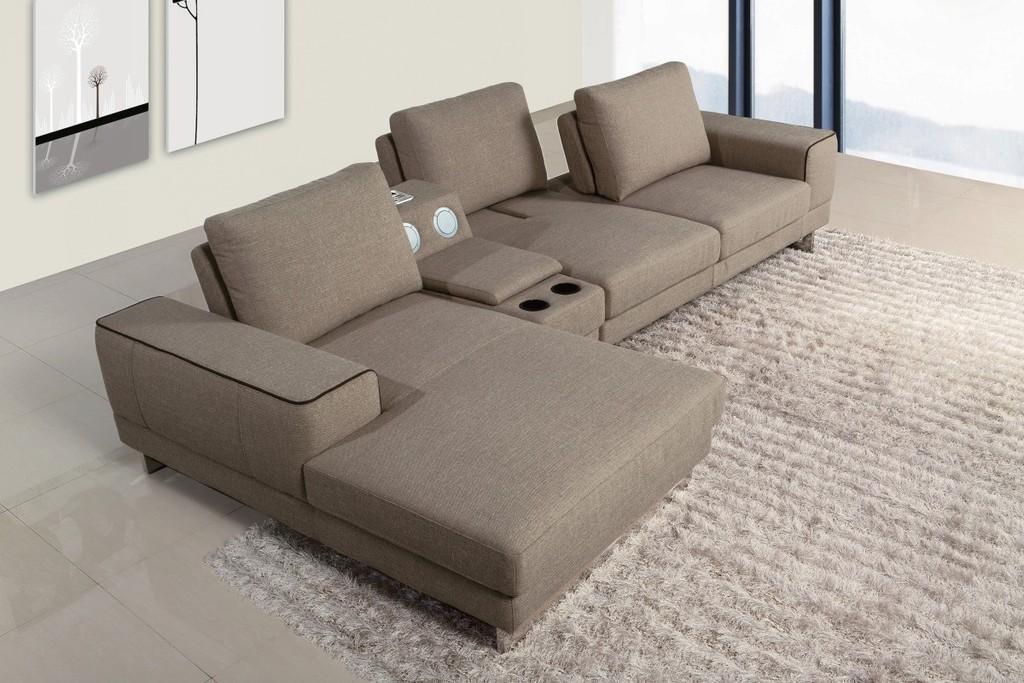Please provide a concise description of this image. Here we can see a sofa set on the carpet, and at back here is the wall and photo frame on it, and here is the glass door. 